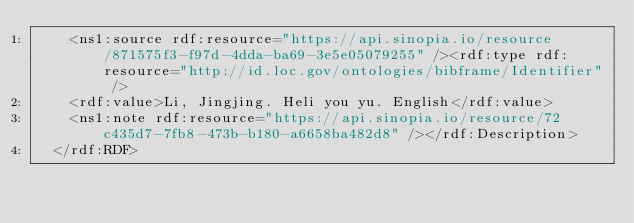Convert code to text. <code><loc_0><loc_0><loc_500><loc_500><_XML_>    <ns1:source rdf:resource="https://api.sinopia.io/resource/871575f3-f97d-4dda-ba69-3e5e05079255" /><rdf:type rdf:resource="http://id.loc.gov/ontologies/bibframe/Identifier" />
    <rdf:value>Li, Jingjing. Heli you yu. English</rdf:value>
    <ns1:note rdf:resource="https://api.sinopia.io/resource/72c435d7-7fb8-473b-b180-a6658ba482d8" /></rdf:Description>
  </rdf:RDF></code> 